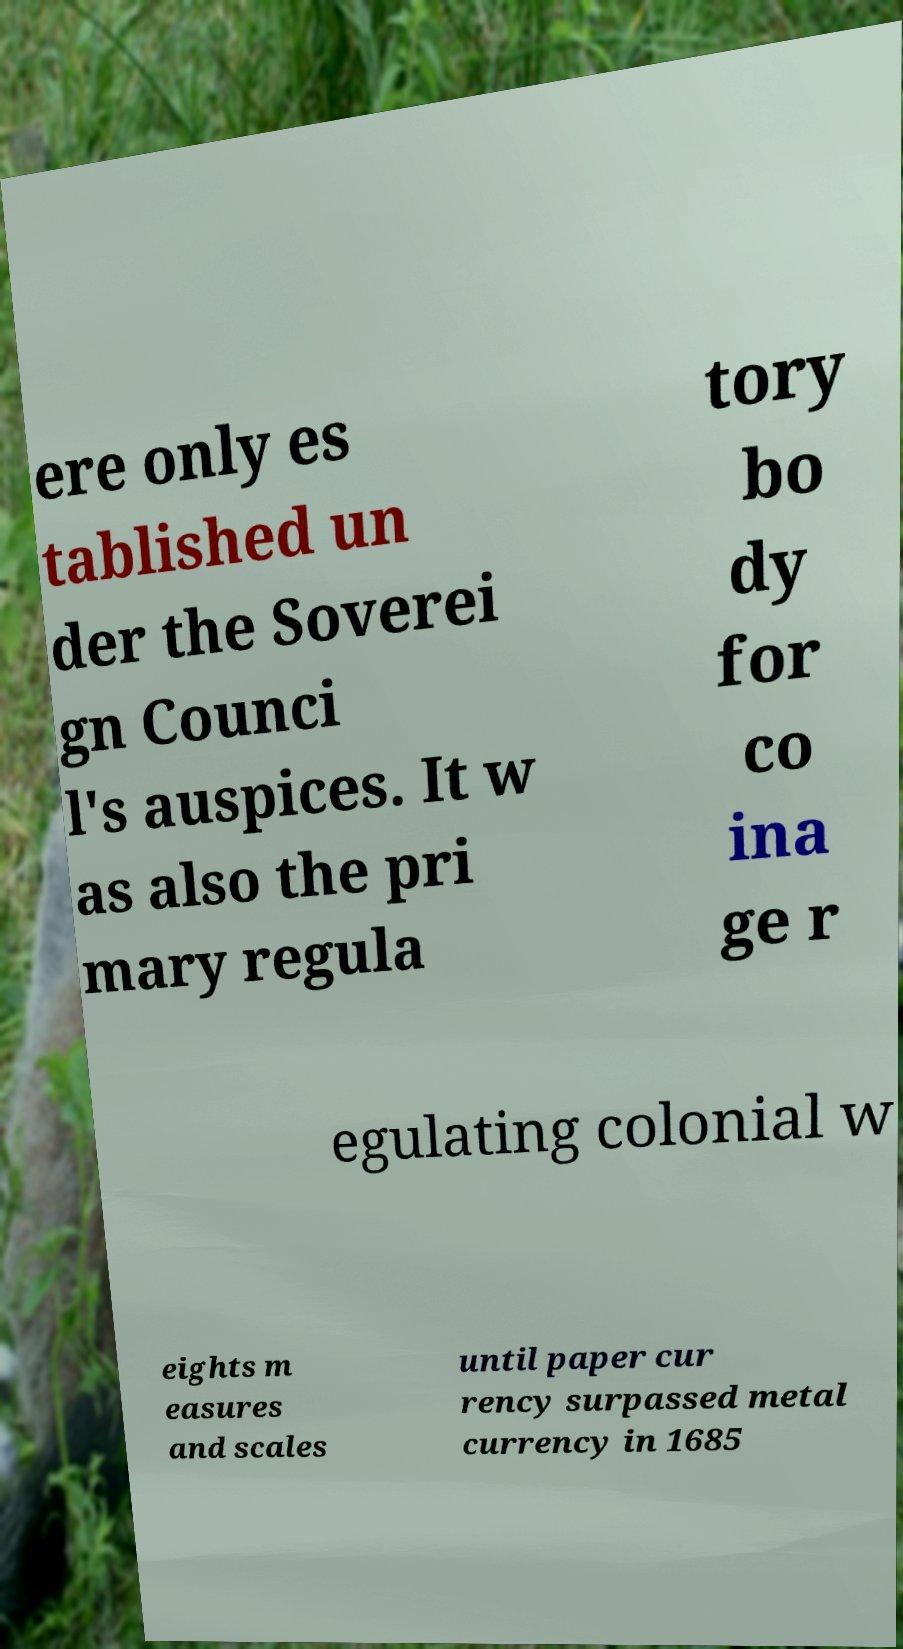What messages or text are displayed in this image? I need them in a readable, typed format. ere only es tablished un der the Soverei gn Counci l's auspices. It w as also the pri mary regula tory bo dy for co ina ge r egulating colonial w eights m easures and scales until paper cur rency surpassed metal currency in 1685 